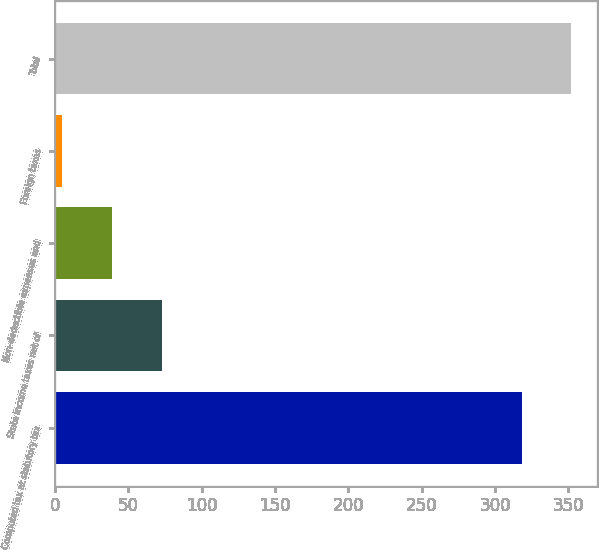Convert chart to OTSL. <chart><loc_0><loc_0><loc_500><loc_500><bar_chart><fcel>Computed tax at statutory tax<fcel>State income taxes net of<fcel>Non-deductible expenses and<fcel>Foreign taxes<fcel>Total<nl><fcel>318<fcel>72.6<fcel>38.8<fcel>5<fcel>351.8<nl></chart> 